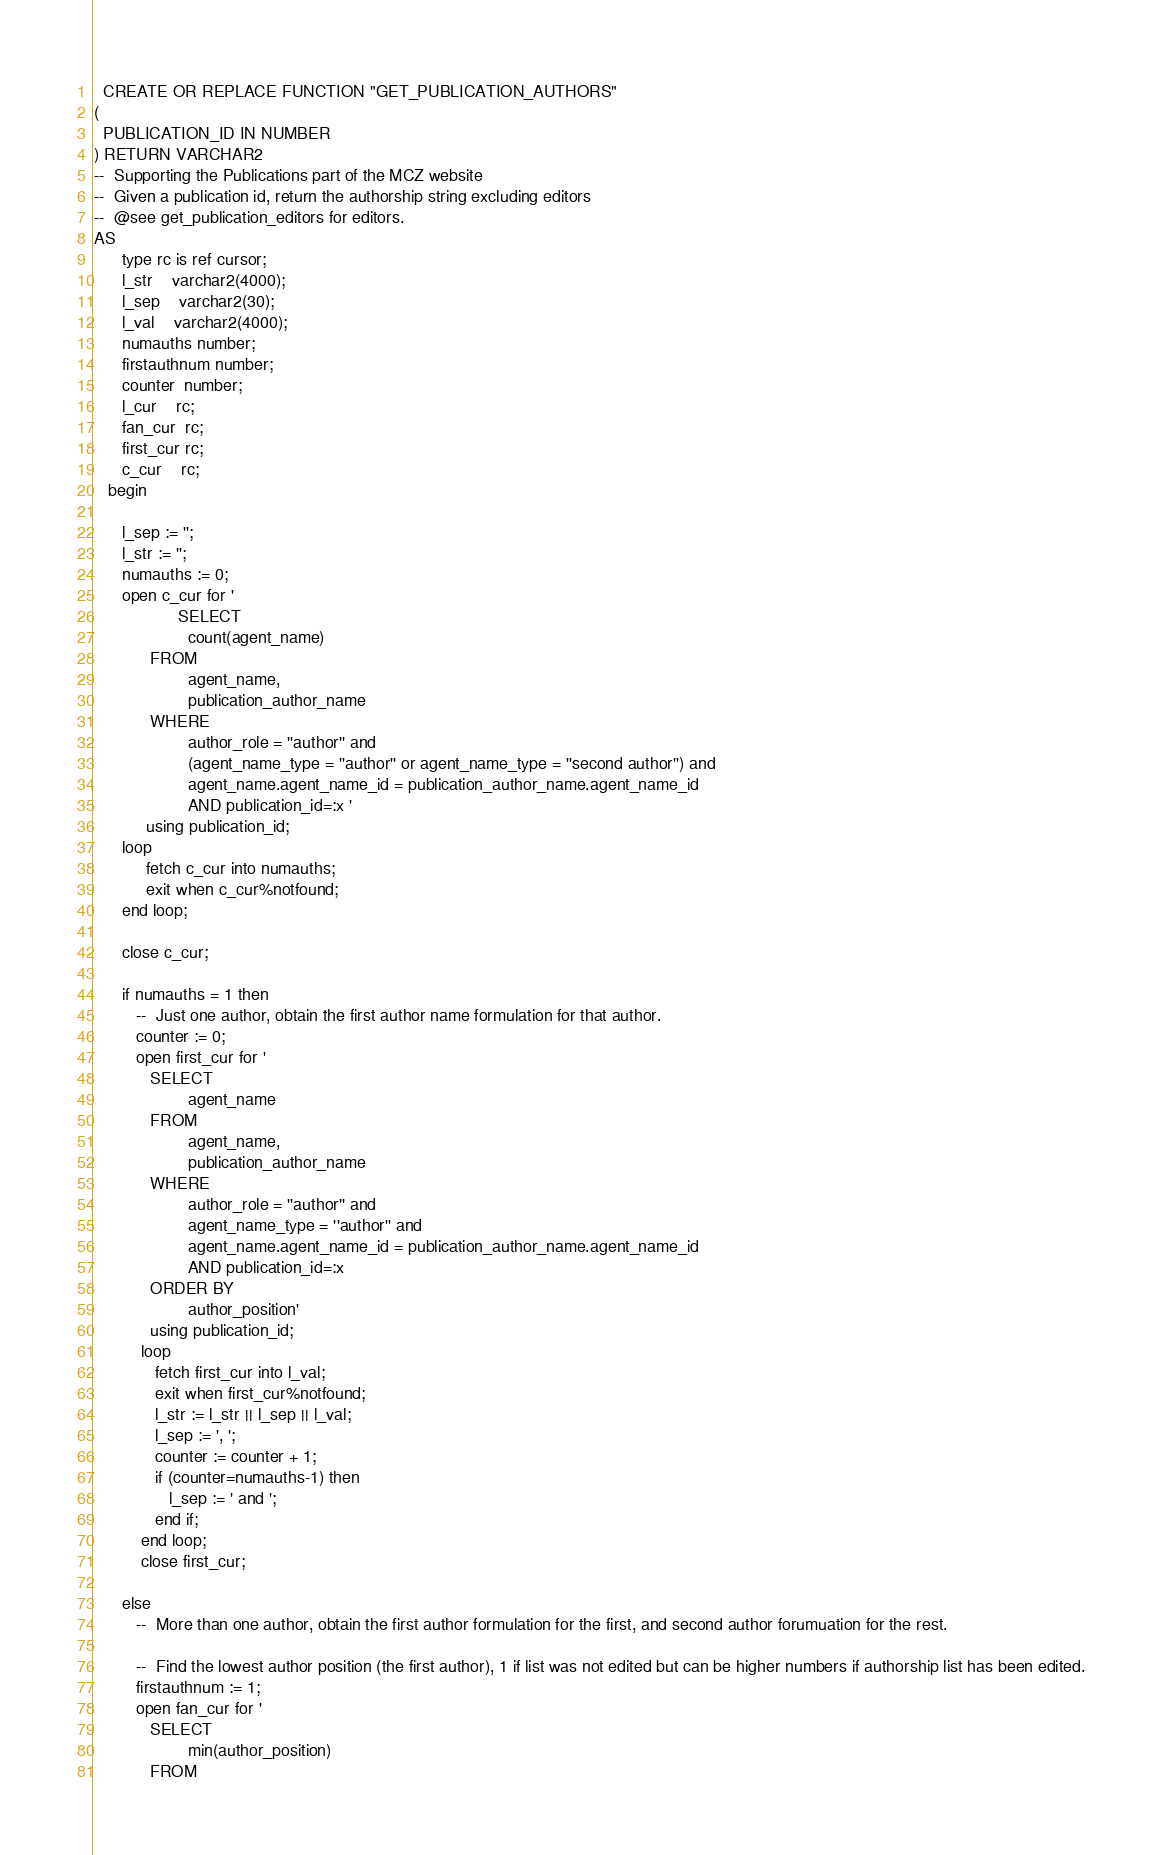Convert code to text. <code><loc_0><loc_0><loc_500><loc_500><_SQL_>
  CREATE OR REPLACE FUNCTION "GET_PUBLICATION_AUTHORS" 
(
  PUBLICATION_ID IN NUMBER  
) RETURN VARCHAR2 
--  Supporting the Publications part of the MCZ website  
--  Given a publication id, return the authorship string excluding editors 
--  @see get_publication_editors for editors.
AS 
      type rc is ref cursor;
      l_str    varchar2(4000);
      l_sep    varchar2(30);
      l_val    varchar2(4000);
      numauths number;
      firstauthnum number;
      counter  number;
      l_cur    rc;
      fan_cur  rc;
      first_cur rc;
      c_cur    rc;
   begin

      l_sep := '';
      l_str := '';
      numauths := 0;
      open c_cur for '
                  SELECT
                    count(agent_name)
            FROM
                    agent_name,
                    publication_author_name
            WHERE
                    author_role = ''author'' and 
                    (agent_name_type = ''author'' or agent_name_type = ''second author'') and
                    agent_name.agent_name_id = publication_author_name.agent_name_id
                    AND publication_id=:x '
           using publication_id; 
      loop
           fetch c_cur into numauths;
           exit when c_cur%notfound;
      end loop;
      
      close c_cur;
      
      if numauths = 1 then 
         --  Just one author, obtain the first author name formulation for that author.
         counter := 0;
         open first_cur for '
            SELECT
                    agent_name
            FROM
                    agent_name,
                    publication_author_name
            WHERE
                    author_role = ''author'' and
                    agent_name_type = ''author'' and
                    agent_name.agent_name_id = publication_author_name.agent_name_id
                    AND publication_id=:x
            ORDER BY
                    author_position'
            using publication_id;
          loop
             fetch first_cur into l_val;
             exit when first_cur%notfound;
             l_str := l_str || l_sep || l_val;
             l_sep := ', ';           
             counter := counter + 1;
             if (counter=numauths-1) then 
                l_sep := ' and ';
             end if;
          end loop;
          close first_cur;
       
      else
         --  More than one author, obtain the first author formulation for the first, and second author forumuation for the rest.
         
         --  Find the lowest author position (the first author), 1 if list was not edited but can be higher numbers if authorship list has been edited.
         firstauthnum := 1;
         open fan_cur for '
            SELECT
                    min(author_position)
            FROM</code> 